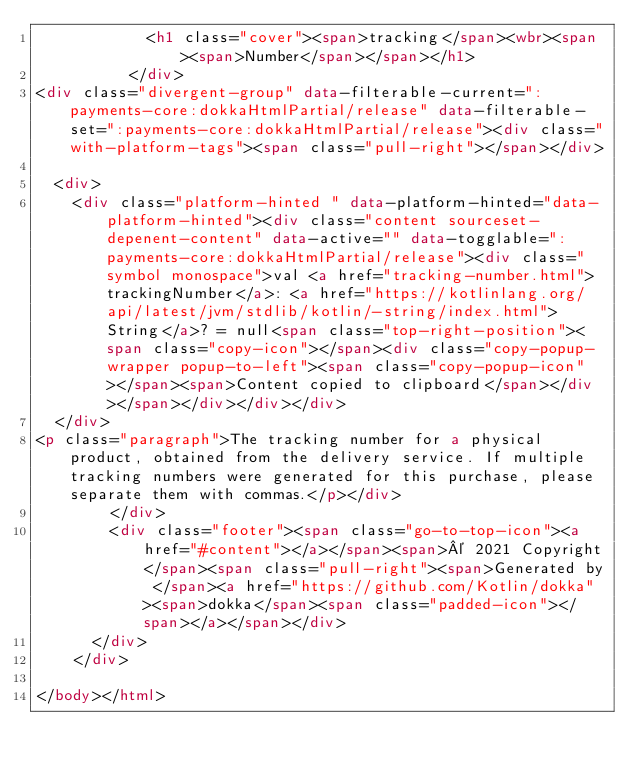Convert code to text. <code><loc_0><loc_0><loc_500><loc_500><_HTML_>            <h1 class="cover"><span>tracking</span><wbr><span><span>Number</span></span></h1>
          </div>
<div class="divergent-group" data-filterable-current=":payments-core:dokkaHtmlPartial/release" data-filterable-set=":payments-core:dokkaHtmlPartial/release"><div class="with-platform-tags"><span class="pull-right"></span></div>

  <div>
    <div class="platform-hinted " data-platform-hinted="data-platform-hinted"><div class="content sourceset-depenent-content" data-active="" data-togglable=":payments-core:dokkaHtmlPartial/release"><div class="symbol monospace">val <a href="tracking-number.html">trackingNumber</a>: <a href="https://kotlinlang.org/api/latest/jvm/stdlib/kotlin/-string/index.html">String</a>? = null<span class="top-right-position"><span class="copy-icon"></span><div class="copy-popup-wrapper popup-to-left"><span class="copy-popup-icon"></span><span>Content copied to clipboard</span></div></span></div></div></div>
  </div>
<p class="paragraph">The tracking number for a physical product, obtained from the delivery service. If multiple tracking numbers were generated for this purchase, please separate them with commas.</p></div>
        </div>
        <div class="footer"><span class="go-to-top-icon"><a href="#content"></a></span><span>© 2021 Copyright</span><span class="pull-right"><span>Generated by </span><a href="https://github.com/Kotlin/dokka"><span>dokka</span><span class="padded-icon"></span></a></span></div>
      </div>
    </div>
  
</body></html>


</code> 